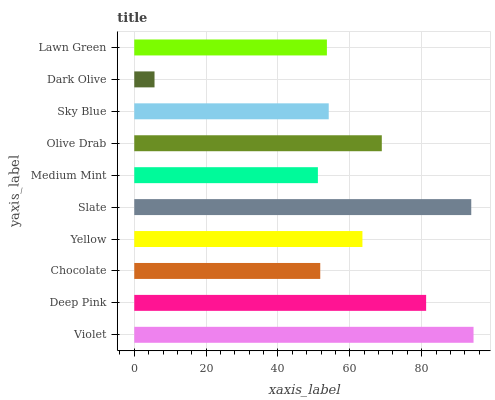Is Dark Olive the minimum?
Answer yes or no. Yes. Is Violet the maximum?
Answer yes or no. Yes. Is Deep Pink the minimum?
Answer yes or no. No. Is Deep Pink the maximum?
Answer yes or no. No. Is Violet greater than Deep Pink?
Answer yes or no. Yes. Is Deep Pink less than Violet?
Answer yes or no. Yes. Is Deep Pink greater than Violet?
Answer yes or no. No. Is Violet less than Deep Pink?
Answer yes or no. No. Is Yellow the high median?
Answer yes or no. Yes. Is Sky Blue the low median?
Answer yes or no. Yes. Is Violet the high median?
Answer yes or no. No. Is Violet the low median?
Answer yes or no. No. 